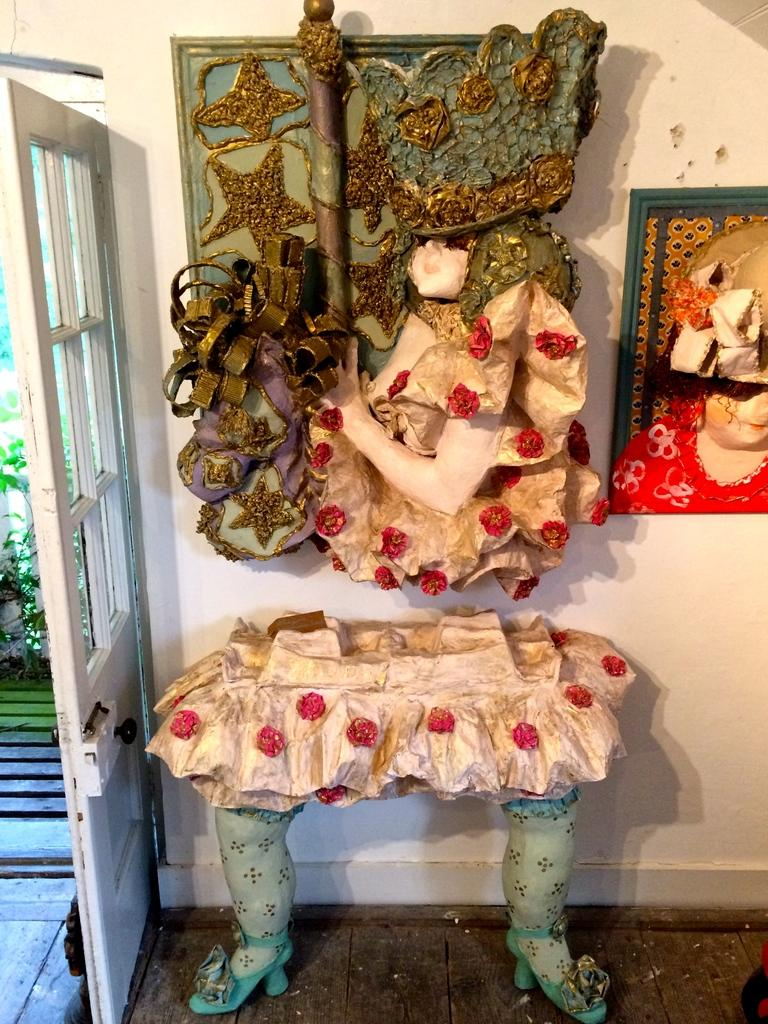What is unique about the table in the image? The table in the image resembles the legs of a person. What can be seen on the wall in the image? There are sculptures on the wall in the image. What feature is present on the door in the image? There is a door handle on the door in the image. What type of vegetation is present in the image? Leaves are present in the image. What other objects can be seen in the image? There are other objects visible in the image. What type of chess pieces are visible on the table in the image? There are no chess pieces visible on the table in the image. What is the calculator used for in the image? There is no calculator present in the image. 